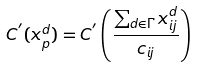<formula> <loc_0><loc_0><loc_500><loc_500>C ^ { ^ { \prime } } ( x _ { p } ^ { d } ) = C ^ { ^ { \prime } } \left ( \frac { \sum _ { d \in \Gamma } x _ { i j } ^ { d } } { c _ { i j } } \right )</formula> 